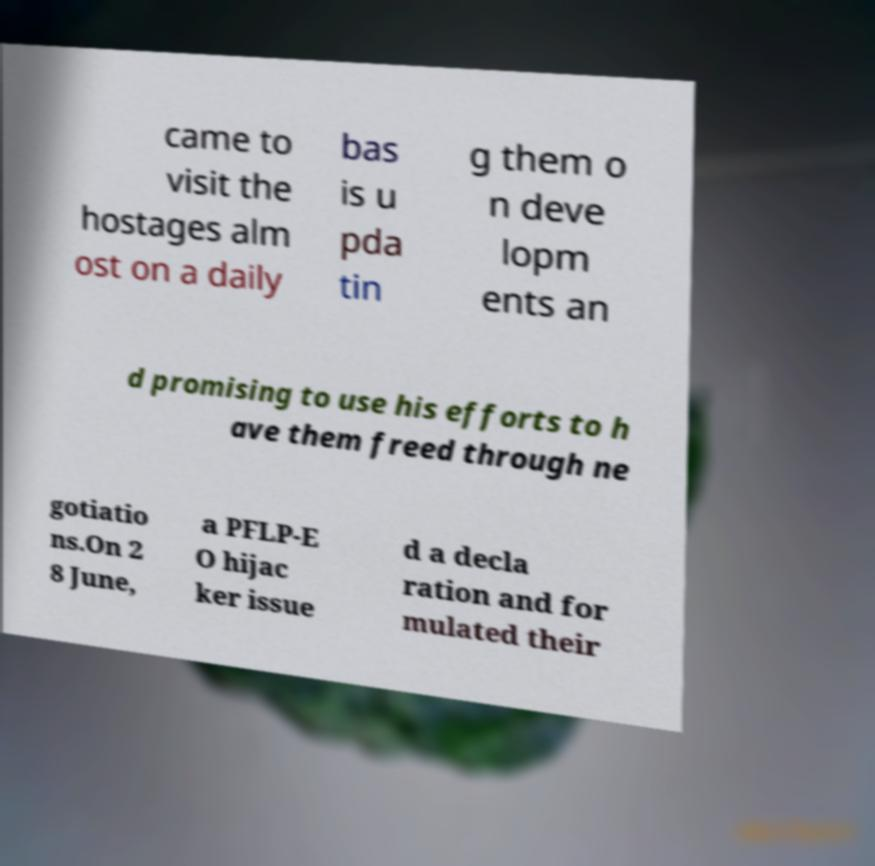There's text embedded in this image that I need extracted. Can you transcribe it verbatim? came to visit the hostages alm ost on a daily bas is u pda tin g them o n deve lopm ents an d promising to use his efforts to h ave them freed through ne gotiatio ns.On 2 8 June, a PFLP-E O hijac ker issue d a decla ration and for mulated their 